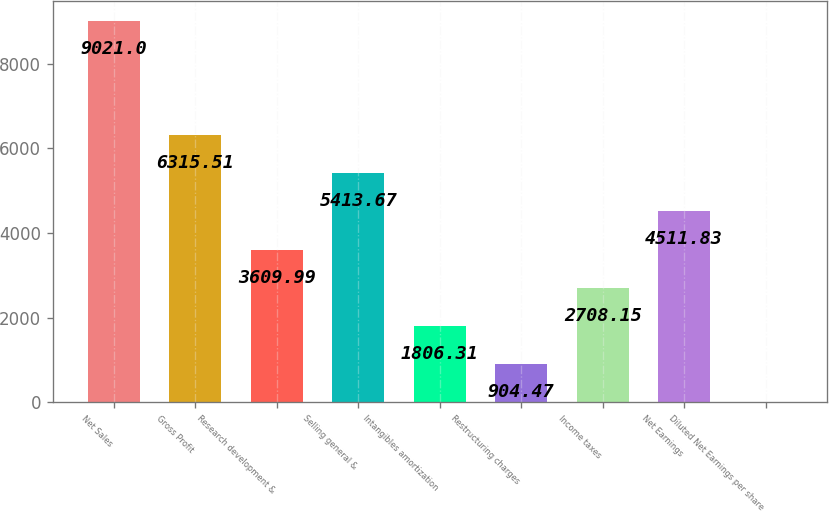<chart> <loc_0><loc_0><loc_500><loc_500><bar_chart><fcel>Net Sales<fcel>Gross Profit<fcel>Research development &<fcel>Selling general &<fcel>Intangibles amortization<fcel>Restructuring charges<fcel>Income taxes<fcel>Net Earnings<fcel>Diluted Net Earnings per share<nl><fcel>9021<fcel>6315.51<fcel>3609.99<fcel>5413.67<fcel>1806.31<fcel>904.47<fcel>2708.15<fcel>4511.83<fcel>2.63<nl></chart> 